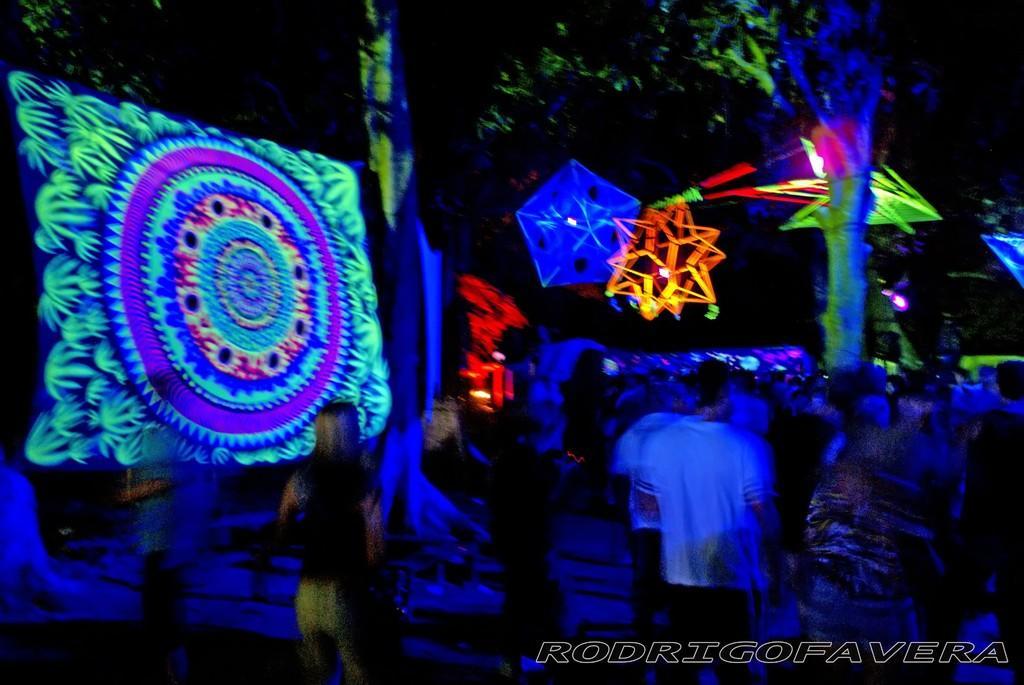Could you give a brief overview of what you see in this image? This image is taken during the night time. At the bottom there are few people who are standing on the floor. At the top there are crafts to which there are lights. On the left side, it looks a screen on which there is some art like design. In the background there are trees. 